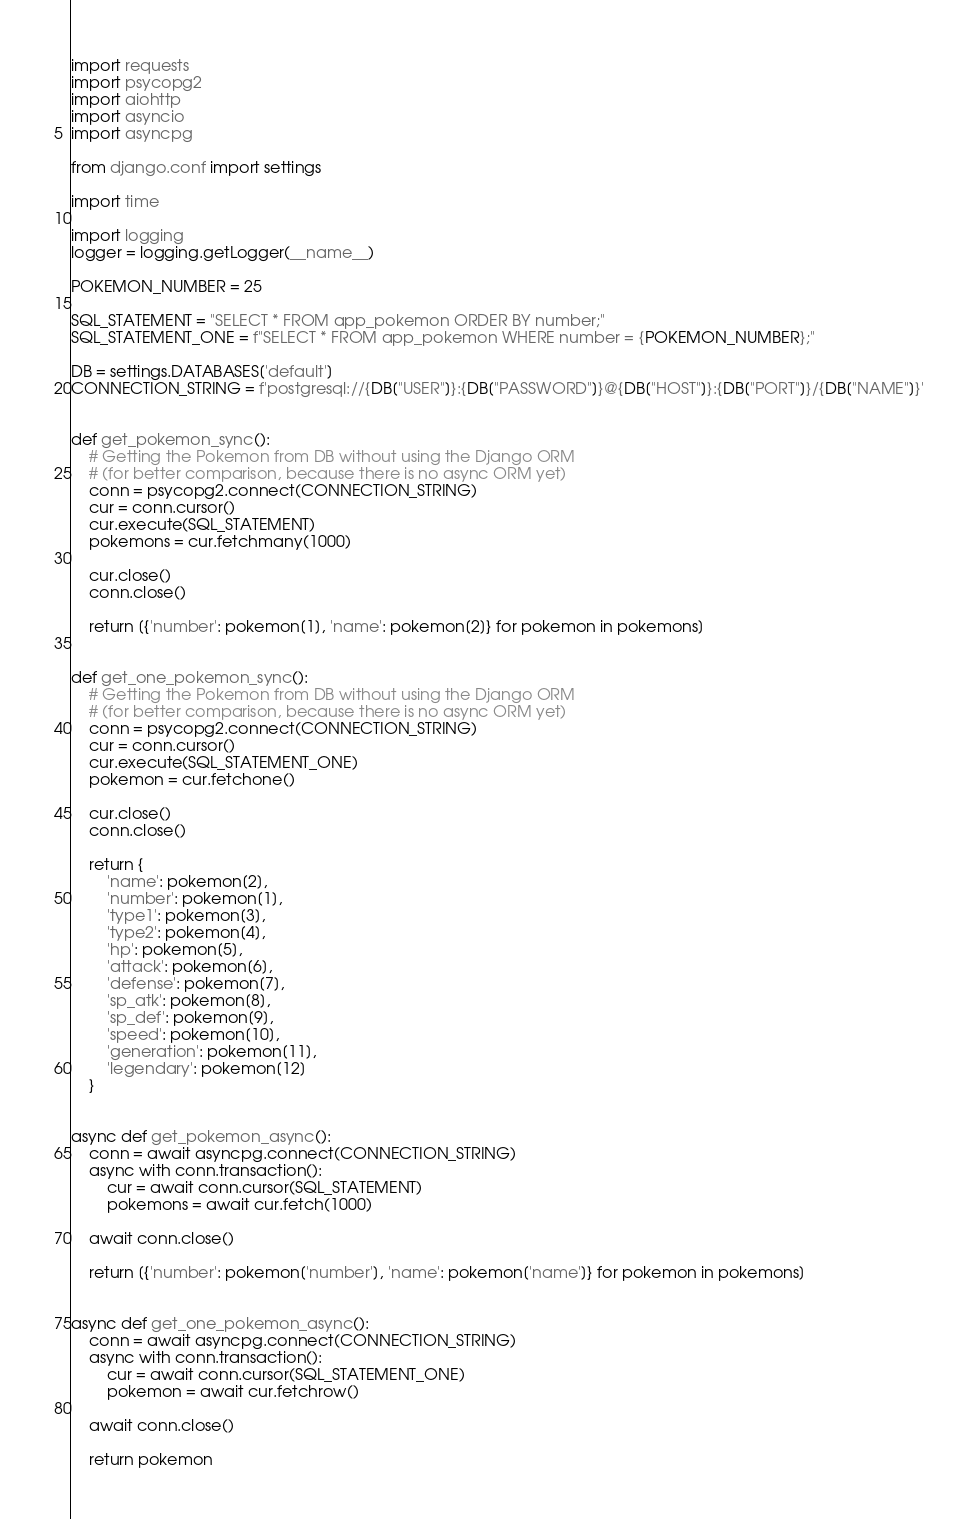Convert code to text. <code><loc_0><loc_0><loc_500><loc_500><_Python_>import requests
import psycopg2
import aiohttp
import asyncio
import asyncpg

from django.conf import settings

import time

import logging
logger = logging.getLogger(__name__)

POKEMON_NUMBER = 25

SQL_STATEMENT = "SELECT * FROM app_pokemon ORDER BY number;"
SQL_STATEMENT_ONE = f"SELECT * FROM app_pokemon WHERE number = {POKEMON_NUMBER};"

DB = settings.DATABASES['default']
CONNECTION_STRING = f'postgresql://{DB["USER"]}:{DB["PASSWORD"]}@{DB["HOST"]}:{DB["PORT"]}/{DB["NAME"]}'


def get_pokemon_sync():
    # Getting the Pokemon from DB without using the Django ORM
    # (for better comparison, because there is no async ORM yet)
    conn = psycopg2.connect(CONNECTION_STRING)
    cur = conn.cursor()
    cur.execute(SQL_STATEMENT)
    pokemons = cur.fetchmany(1000)

    cur.close()
    conn.close()

    return [{'number': pokemon[1], 'name': pokemon[2]} for pokemon in pokemons]


def get_one_pokemon_sync():
    # Getting the Pokemon from DB without using the Django ORM
    # (for better comparison, because there is no async ORM yet)
    conn = psycopg2.connect(CONNECTION_STRING)
    cur = conn.cursor()
    cur.execute(SQL_STATEMENT_ONE)
    pokemon = cur.fetchone()

    cur.close()
    conn.close()

    return {
        'name': pokemon[2],
        'number': pokemon[1],
        'type1': pokemon[3],
        'type2': pokemon[4],
        'hp': pokemon[5],
        'attack': pokemon[6],
        'defense': pokemon[7],
        'sp_atk': pokemon[8],
        'sp_def': pokemon[9],
        'speed': pokemon[10],
        'generation': pokemon[11],
        'legendary': pokemon[12]
    }


async def get_pokemon_async():
    conn = await asyncpg.connect(CONNECTION_STRING)
    async with conn.transaction():
        cur = await conn.cursor(SQL_STATEMENT)
        pokemons = await cur.fetch(1000)

    await conn.close()

    return [{'number': pokemon['number'], 'name': pokemon['name']} for pokemon in pokemons]


async def get_one_pokemon_async():
    conn = await asyncpg.connect(CONNECTION_STRING)
    async with conn.transaction():
        cur = await conn.cursor(SQL_STATEMENT_ONE)
        pokemon = await cur.fetchrow()

    await conn.close()

    return pokemon
</code> 